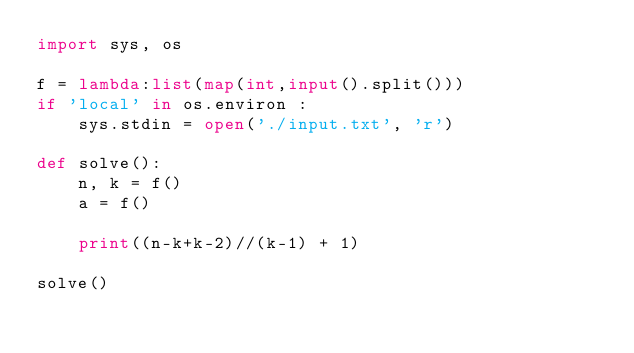<code> <loc_0><loc_0><loc_500><loc_500><_Python_>import sys, os

f = lambda:list(map(int,input().split()))
if 'local' in os.environ :
    sys.stdin = open('./input.txt', 'r')

def solve():
    n, k = f()
    a = f()

    print((n-k+k-2)//(k-1) + 1)

solve()
</code> 